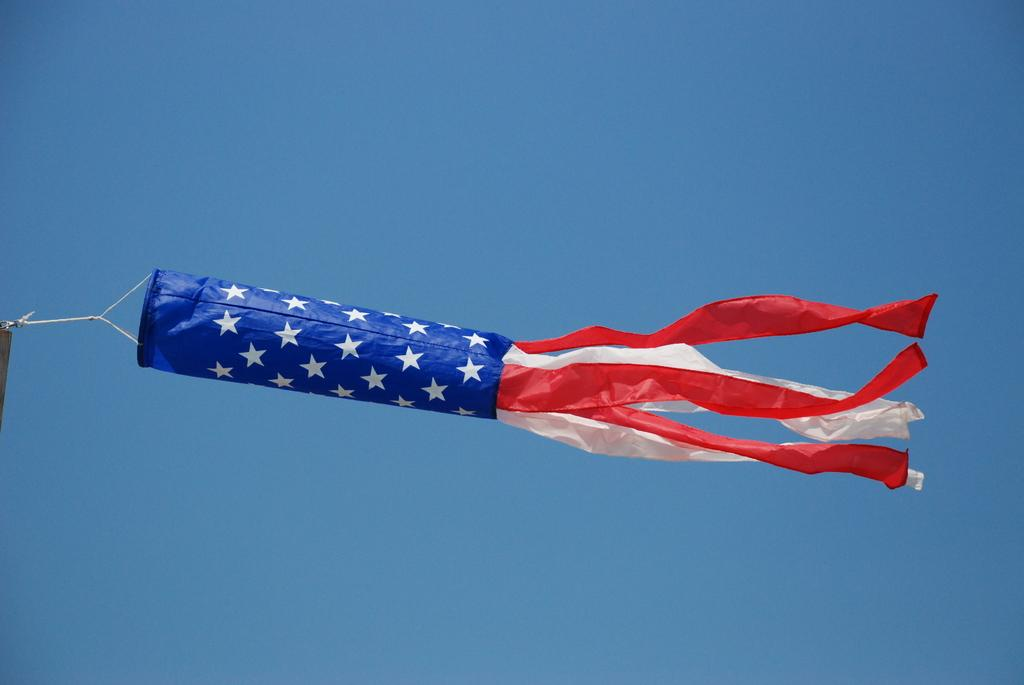What object is present in the image that represents a country or organization? There is a flag in the image. What colors are present on the flag? The flag has blue, white, and red colors. What can be seen in the background of the image? The sky is visible in the background of the image. What is the color of the sky in the image? A: The sky is blue in color. What type of industry can be seen in the image? There is no industry present in the image. 